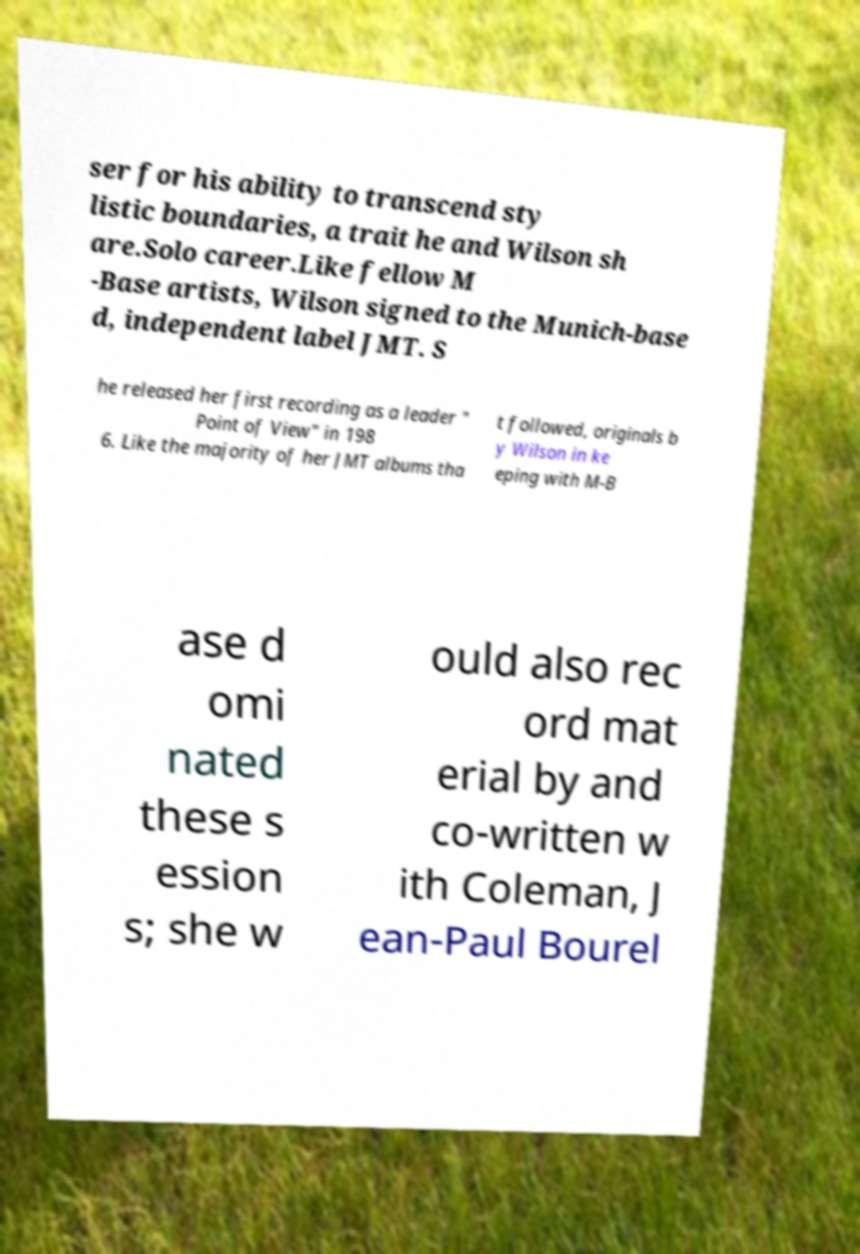What messages or text are displayed in this image? I need them in a readable, typed format. ser for his ability to transcend sty listic boundaries, a trait he and Wilson sh are.Solo career.Like fellow M -Base artists, Wilson signed to the Munich-base d, independent label JMT. S he released her first recording as a leader " Point of View" in 198 6. Like the majority of her JMT albums tha t followed, originals b y Wilson in ke eping with M-B ase d omi nated these s ession s; she w ould also rec ord mat erial by and co-written w ith Coleman, J ean-Paul Bourel 